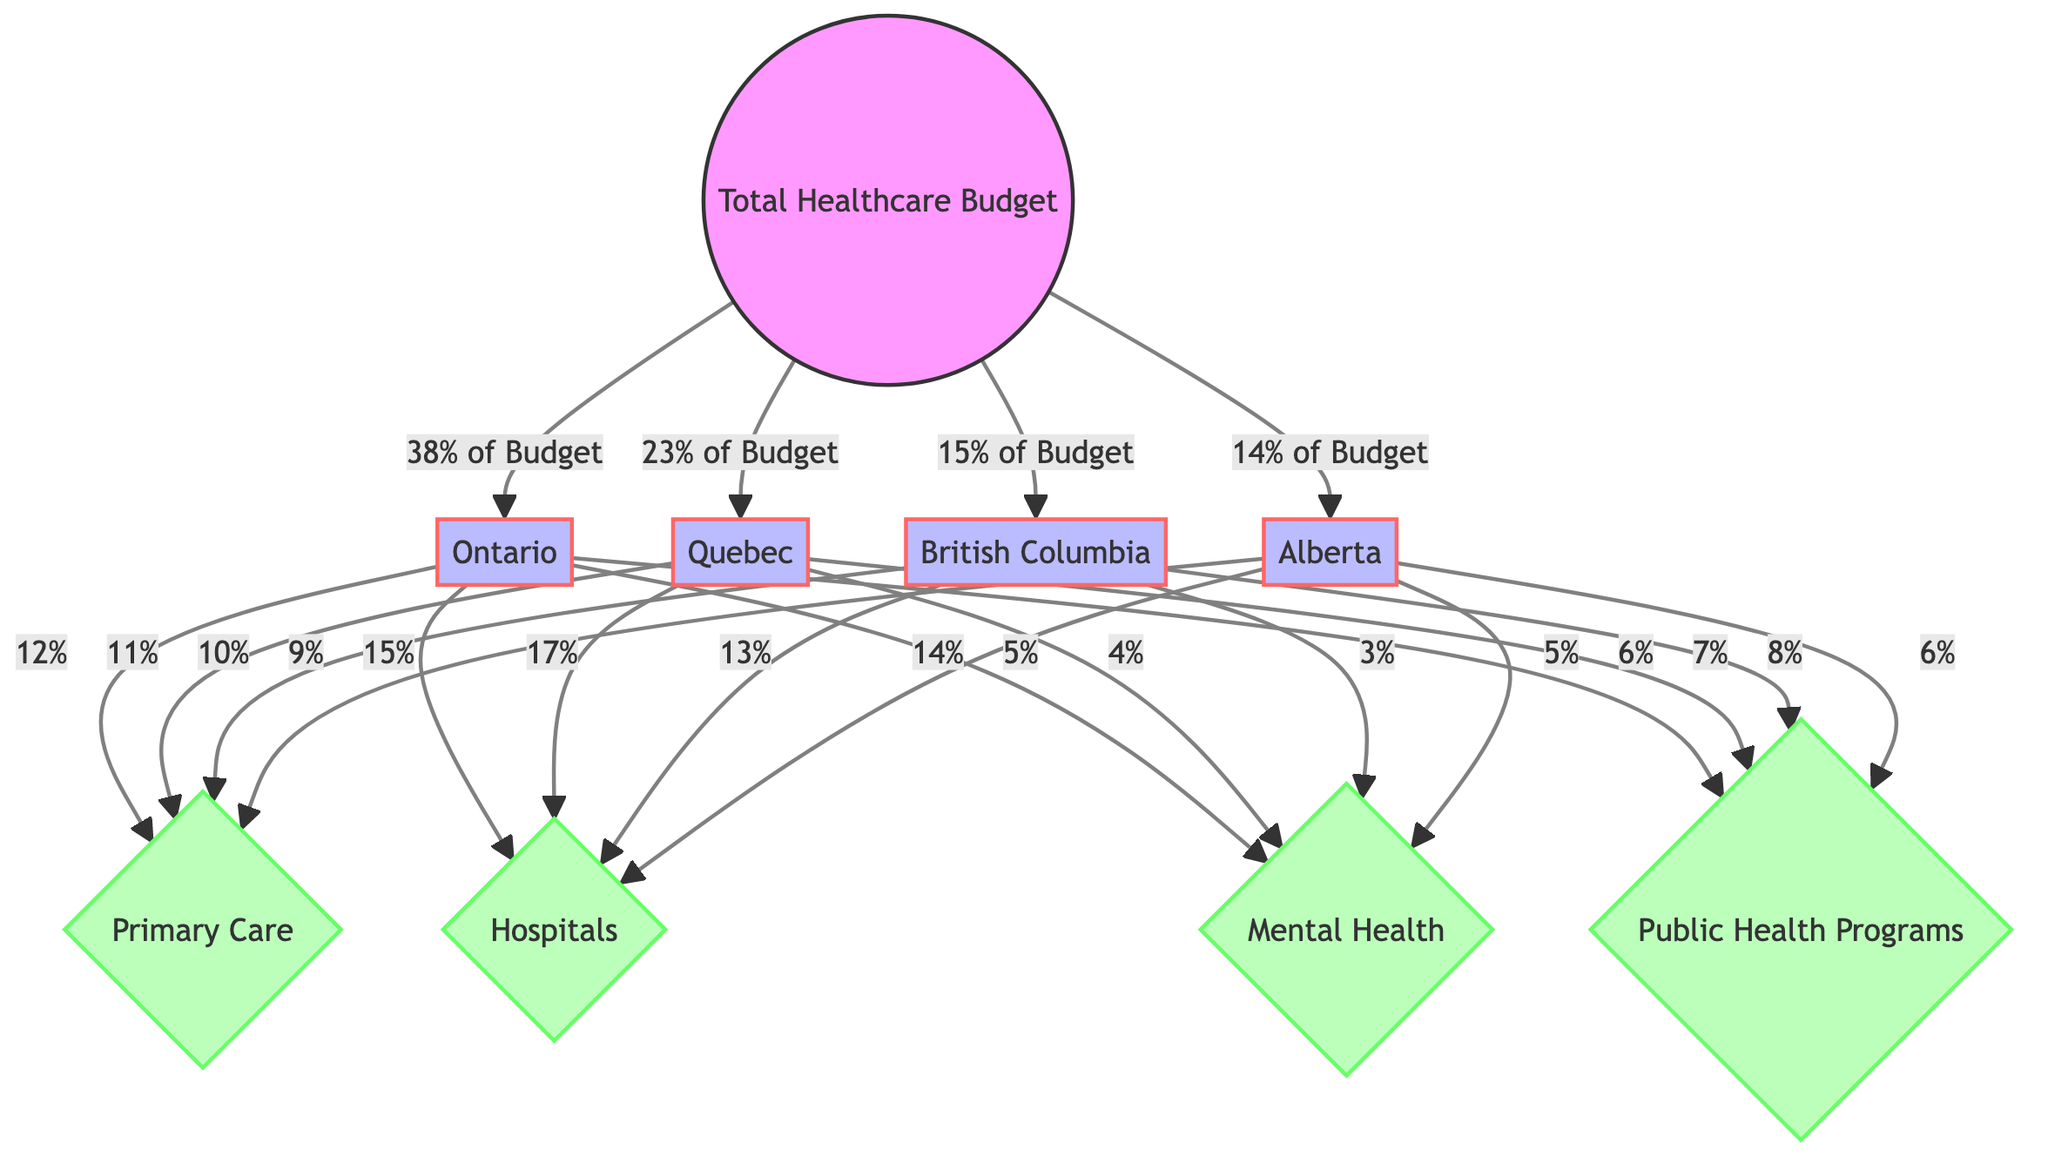What percentage of the total healthcare budget is allocated to Ontario? The total healthcare budget is divided among several provinces, with Ontario receiving 38% of the total budget as indicated by the arrow leading from the total healthcare budget node to the Ontario node.
Answer: 38% Which province has the highest allocation for hospitals? By reviewing the allocations for hospitals from each province, we see that Ontario has the highest at 15%, as shown by the arrows linking Ontario to the hospitals category.
Answer: Ontario How many categories are represented in this diagram? The diagram includes four distinct categories that represent different areas of healthcare funding, namely Primary Care, Hospitals, Mental Health, and Public Health Programs. Counted collectively, these represent the categories distinctly linked below the provinces.
Answer: 4 What is the combined percentage allocated to Mental Health across all provinces? To find the total for Mental Health, we add the percentages from each province: 5% (Ontario) + 4% (Quebec) + 3% (British Columbia) + 5% (Alberta) = 17%. This requires summing the values shown with arrows leading to Mental Health from all the provinces.
Answer: 17% Which province allocates the smallest percentage to Public Health Programs? By examining the percentages associated with Public Health Programs in each province, we can see Alberta allocates the smallest percentage at 6%, indicated by the arrow connecting it to the category.
Answer: Alberta What is the total percentage allocated to Primary Care across all provinces? To determine the total for Primary Care, we add the allocations from each province: 12% (Ontario) + 11% (Quebec) + 10% (British Columbia) + 9% (Alberta) = 42%. This is done by summing the individual contributions represented by the arrows pointing to Primary Care from each province.
Answer: 42% Which category receives the least percentage from British Columbia? The category receiving the least percentage from British Columbia is Mental Health, which has an allocation of 3%, shown by the arrow from the British Columbia node to the Mental Health category.
Answer: Mental Health What is the proportion of the total budget allocated to the combined spending on Primary Care and Mental Health in Quebec? To find this, we will add the percentages allocated to both categories in Quebec: 11% (Primary Care) + 4% (Mental Health) = 15%. The values are taken from the respective arrows pointing to the categories from the Quebec node.
Answer: 15% 